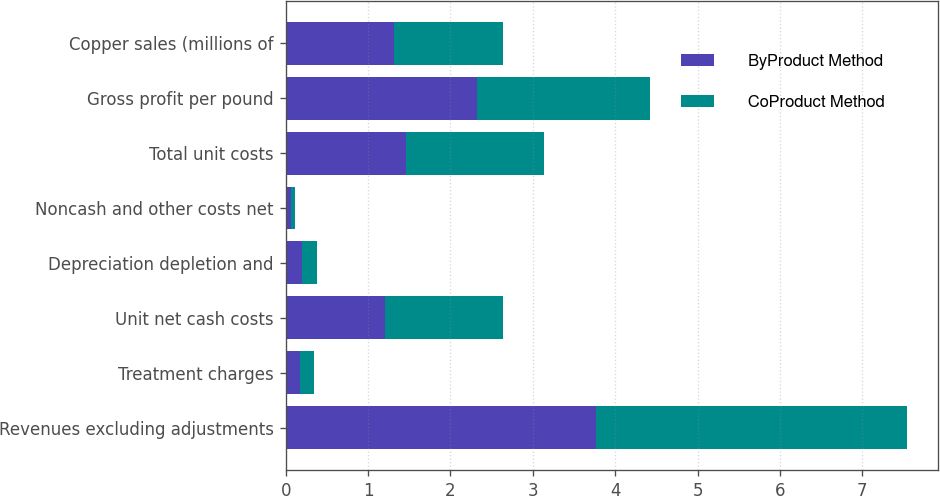<chart> <loc_0><loc_0><loc_500><loc_500><stacked_bar_chart><ecel><fcel>Revenues excluding adjustments<fcel>Treatment charges<fcel>Unit net cash costs<fcel>Depreciation depletion and<fcel>Noncash and other costs net<fcel>Total unit costs<fcel>Gross profit per pound<fcel>Copper sales (millions of<nl><fcel>ByProduct Method<fcel>3.77<fcel>0.17<fcel>1.2<fcel>0.2<fcel>0.06<fcel>1.46<fcel>2.32<fcel>1.32<nl><fcel>CoProduct Method<fcel>3.77<fcel>0.17<fcel>1.44<fcel>0.18<fcel>0.05<fcel>1.67<fcel>2.1<fcel>1.32<nl></chart> 